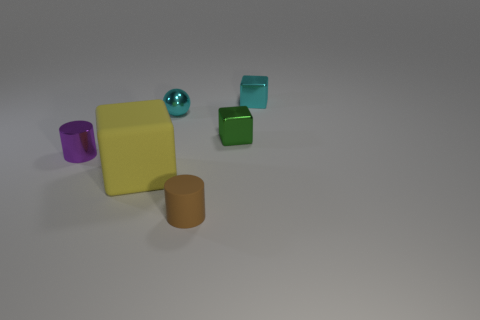What colors are the objects in the image, and how many objects are there of each color? The image contains a variety of colored objects including one purple object, two green objects, one yellow object, one turquoise object, and one brown object, making a total of six objects with unique hues. 